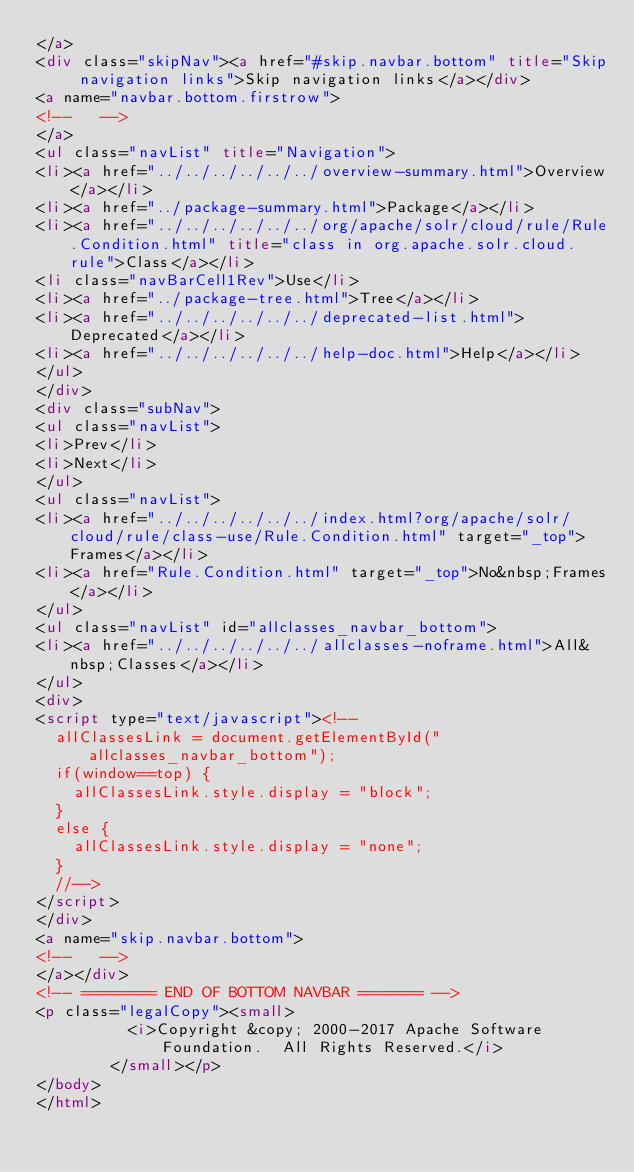Convert code to text. <code><loc_0><loc_0><loc_500><loc_500><_HTML_></a>
<div class="skipNav"><a href="#skip.navbar.bottom" title="Skip navigation links">Skip navigation links</a></div>
<a name="navbar.bottom.firstrow">
<!--   -->
</a>
<ul class="navList" title="Navigation">
<li><a href="../../../../../../overview-summary.html">Overview</a></li>
<li><a href="../package-summary.html">Package</a></li>
<li><a href="../../../../../../org/apache/solr/cloud/rule/Rule.Condition.html" title="class in org.apache.solr.cloud.rule">Class</a></li>
<li class="navBarCell1Rev">Use</li>
<li><a href="../package-tree.html">Tree</a></li>
<li><a href="../../../../../../deprecated-list.html">Deprecated</a></li>
<li><a href="../../../../../../help-doc.html">Help</a></li>
</ul>
</div>
<div class="subNav">
<ul class="navList">
<li>Prev</li>
<li>Next</li>
</ul>
<ul class="navList">
<li><a href="../../../../../../index.html?org/apache/solr/cloud/rule/class-use/Rule.Condition.html" target="_top">Frames</a></li>
<li><a href="Rule.Condition.html" target="_top">No&nbsp;Frames</a></li>
</ul>
<ul class="navList" id="allclasses_navbar_bottom">
<li><a href="../../../../../../allclasses-noframe.html">All&nbsp;Classes</a></li>
</ul>
<div>
<script type="text/javascript"><!--
  allClassesLink = document.getElementById("allclasses_navbar_bottom");
  if(window==top) {
    allClassesLink.style.display = "block";
  }
  else {
    allClassesLink.style.display = "none";
  }
  //-->
</script>
</div>
<a name="skip.navbar.bottom">
<!--   -->
</a></div>
<!-- ======== END OF BOTTOM NAVBAR ======= -->
<p class="legalCopy"><small>
          <i>Copyright &copy; 2000-2017 Apache Software Foundation.  All Rights Reserved.</i>
        </small></p>
</body>
</html>
</code> 